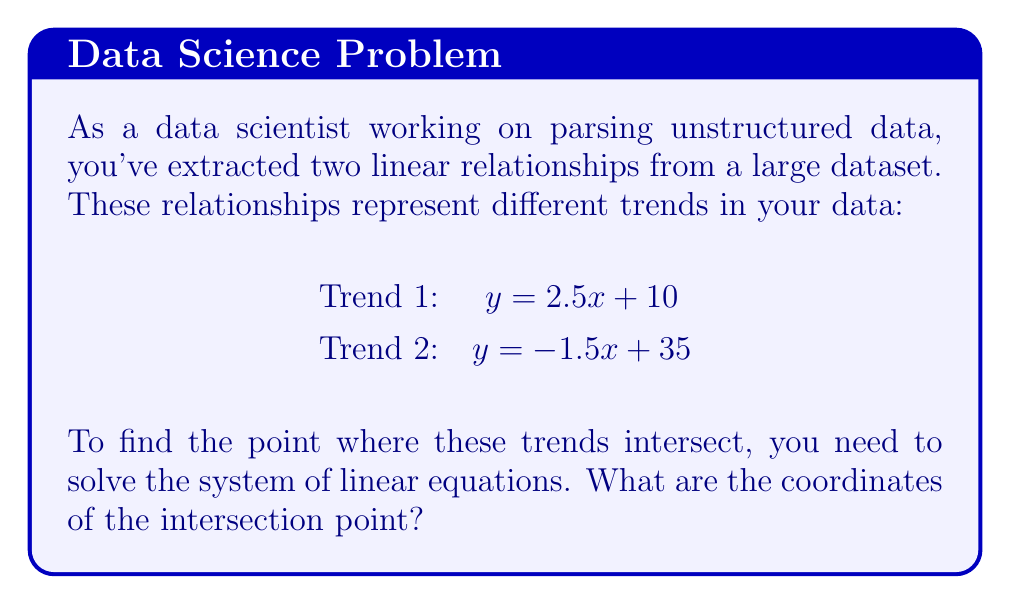Give your solution to this math problem. To solve this system of linear equations, we'll use the substitution method:

1) We have two equations:
   $$y = 2.5x + 10$$ (Equation 1)
   $$y = -1.5x + 35$$ (Equation 2)

2) Since both equations are solved for y, we can set them equal to each other:
   $$2.5x + 10 = -1.5x + 35$$

3) Now, let's solve for x:
   $$2.5x + 1.5x = 35 - 10$$
   $$4x = 25$$
   $$x = \frac{25}{4} = 6.25$$

4) Now that we know x, we can substitute this value into either of the original equations to find y. Let's use Equation 1:
   $$y = 2.5(6.25) + 10$$
   $$y = 15.625 + 10 = 25.625$$

5) Therefore, the point of intersection is (6.25, 25.625).

This point represents where the two trends in your data intersect, which could be a significant insight for your analysis.
Answer: The point of intersection is (6.25, 25.625). 